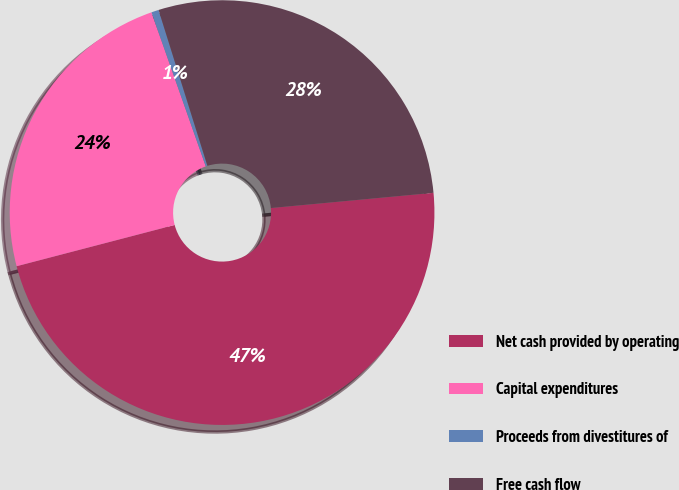Convert chart to OTSL. <chart><loc_0><loc_0><loc_500><loc_500><pie_chart><fcel>Net cash provided by operating<fcel>Capital expenditures<fcel>Proceeds from divestitures of<fcel>Free cash flow<nl><fcel>47.42%<fcel>23.67%<fcel>0.56%<fcel>28.35%<nl></chart> 